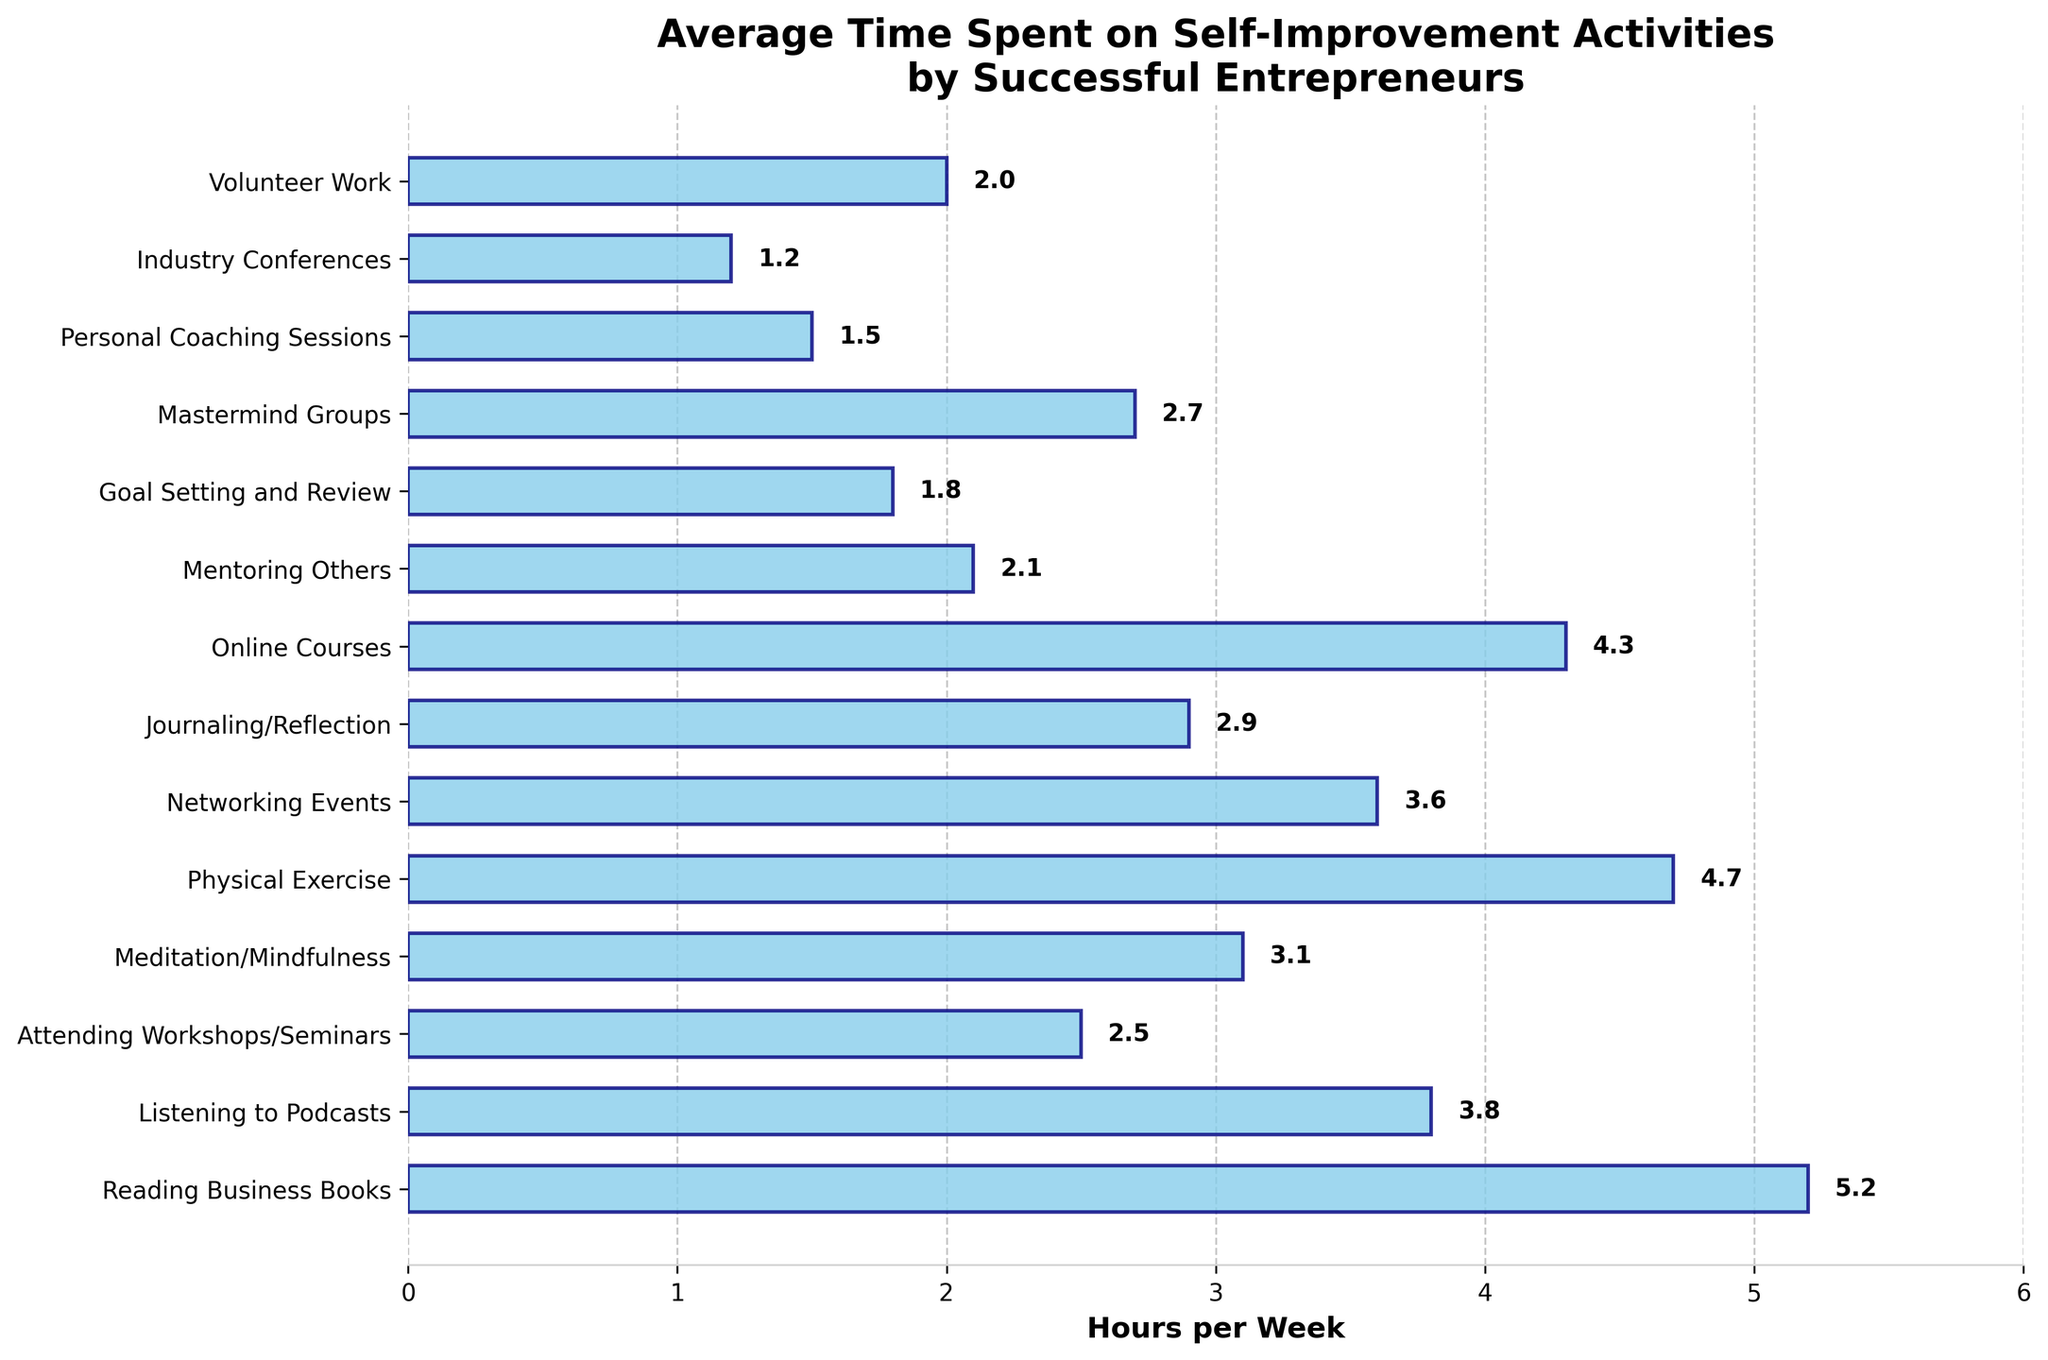What's the activity with the highest average time spent per week? The bar with the greatest length represents the activity with the highest average time spent. From the chart, "Reading Business Books" has the longest bar.
Answer: Reading Business Books Which two activities have the closest average time spent per week, and what are their values? To answer this, locate two bars that are visually the closest in length. "Meditation/Mindfulness" (3.1 hours) and "Journaling/Reflection" (2.9 hours) are very close.
Answer: Meditation/Mindfulness: 3.1, Journaling/Reflection: 2.9 What is the combined average time spent per week on "Physical Exercise" and "Online Courses"? Add the hours for "Physical Exercise" (4.7) and "Online Courses" (4.3). Combined time is 4.7 + 4.3 = 9.0 hours.
Answer: 9.0 hours Which activity has a longer average time spent per week: "Networking Events" or "Attending Workshops/Seminars"? Compare the lengths of the corresponding bars. "Networking Events" (3.6 hours) has a longer bar than "Attending Workshops/Seminars" (2.5 hours).
Answer: Networking Events What is the difference in average time spent per week between "Goal Setting and Review" and "Personal Coaching Sessions"? Subtract the hours of "Personal Coaching Sessions" (1.5) from "Goal Setting and Review" (1.8). Difference is 1.8 - 1.5 = 0.3 hours.
Answer: 0.3 hours What's the average time spent on activities related to learning, including "Reading Business Books," "Listening to Podcasts," "Online Courses," and "Attending Workshops/Seminars"? Sum the hours: 5.2 (Reading Business Books) + 3.8 (Listening to Podcasts) + 4.3 (Online Courses) + 2.5 (Attending Workshops/Seminars). Total is 15.8 hours. Average is 15.8 / 4 = 3.95 hours.
Answer: 3.95 hours How many activities have an average time spent of 2.5 hours or more per week? Count the bars representing 2.5 or more hours. Activities are "Reading Business Books," "Listening to Podcasts," "Meditation/Mindfulness," "Physical Exercise," "Networking Events," "Online Courses," "Journaling/Reflection," and "Mastermind Groups." There are 8 activities.
Answer: 8 activities Which activity has the shortest average time spent per week? The shortest bar represents the activity with the shortest average time spent. "Industry Conferences" has the shortest bar.
Answer: Industry Conferences How much more time is spent on "Physical Exercise" compared to "Volunteer Work"? Subtract the hours of "Volunteer Work" (2.0) from "Physical Exercise" (4.7). The difference is 4.7 - 2.0 = 2.7 hours.
Answer: 2.7 hours What is the median value of the average time spent per week across all activities? Arrange the hours in ascending order: 1.2, 1.5, 1.8, 2.0, 2.1, 2.5, 2.7, 2.9, 3.1, 3.6, 3.8, 4.3, 4.7, 5.2. With 14 data points, the median is the average of the 7th and 8th values: (2.7 + 2.9) / 2 = 2.8 hours.
Answer: 2.8 hours 